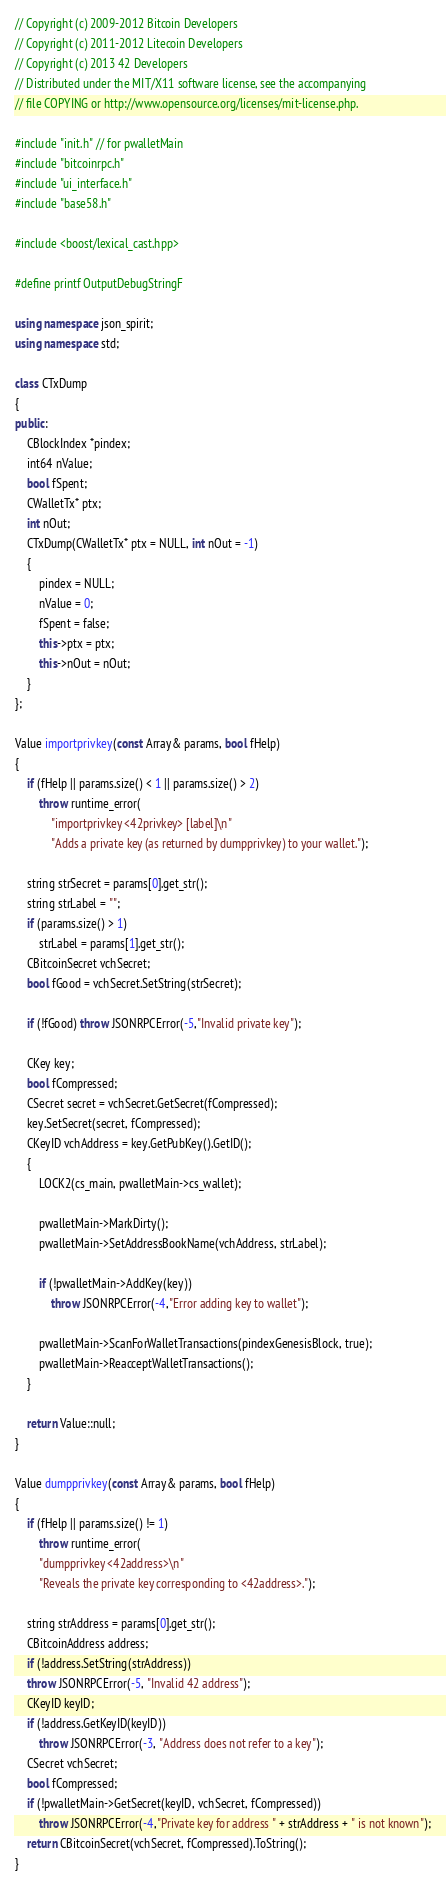<code> <loc_0><loc_0><loc_500><loc_500><_C++_>// Copyright (c) 2009-2012 Bitcoin Developers
// Copyright (c) 2011-2012 Litecoin Developers
// Copyright (c) 2013 42 Developers
// Distributed under the MIT/X11 software license, see the accompanying
// file COPYING or http://www.opensource.org/licenses/mit-license.php.

#include "init.h" // for pwalletMain
#include "bitcoinrpc.h"
#include "ui_interface.h"
#include "base58.h"

#include <boost/lexical_cast.hpp>

#define printf OutputDebugStringF

using namespace json_spirit;
using namespace std;

class CTxDump
{
public:
    CBlockIndex *pindex;
    int64 nValue;
    bool fSpent;
    CWalletTx* ptx;
    int nOut;
    CTxDump(CWalletTx* ptx = NULL, int nOut = -1)
    {
        pindex = NULL;
        nValue = 0;
        fSpent = false;
        this->ptx = ptx;
        this->nOut = nOut;
    }
};

Value importprivkey(const Array& params, bool fHelp)
{
    if (fHelp || params.size() < 1 || params.size() > 2)
        throw runtime_error(
            "importprivkey <42privkey> [label]\n"
            "Adds a private key (as returned by dumpprivkey) to your wallet.");

    string strSecret = params[0].get_str();
    string strLabel = "";
    if (params.size() > 1)
        strLabel = params[1].get_str();
    CBitcoinSecret vchSecret;
    bool fGood = vchSecret.SetString(strSecret);

    if (!fGood) throw JSONRPCError(-5,"Invalid private key");

    CKey key;
    bool fCompressed;
    CSecret secret = vchSecret.GetSecret(fCompressed);
    key.SetSecret(secret, fCompressed);
    CKeyID vchAddress = key.GetPubKey().GetID();
    {
        LOCK2(cs_main, pwalletMain->cs_wallet);

        pwalletMain->MarkDirty();
        pwalletMain->SetAddressBookName(vchAddress, strLabel);

        if (!pwalletMain->AddKey(key))
            throw JSONRPCError(-4,"Error adding key to wallet");

        pwalletMain->ScanForWalletTransactions(pindexGenesisBlock, true);
        pwalletMain->ReacceptWalletTransactions();
    }

    return Value::null;
}

Value dumpprivkey(const Array& params, bool fHelp)
{
    if (fHelp || params.size() != 1)
        throw runtime_error(
        "dumpprivkey <42address>\n"
        "Reveals the private key corresponding to <42address>.");

    string strAddress = params[0].get_str();
    CBitcoinAddress address;
    if (!address.SetString(strAddress))
    throw JSONRPCError(-5, "Invalid 42 address");
    CKeyID keyID;
    if (!address.GetKeyID(keyID))
        throw JSONRPCError(-3, "Address does not refer to a key");
    CSecret vchSecret;
    bool fCompressed;
    if (!pwalletMain->GetSecret(keyID, vchSecret, fCompressed))
        throw JSONRPCError(-4,"Private key for address " + strAddress + " is not known");
    return CBitcoinSecret(vchSecret, fCompressed).ToString();
}
</code> 